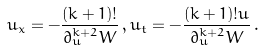<formula> <loc_0><loc_0><loc_500><loc_500>u _ { x } = - \frac { ( k + 1 ) ! } { \partial _ { u } ^ { k + 2 } W } \, , u _ { t } = - \frac { ( k + 1 ) ! u } { \partial _ { u } ^ { k + 2 } W } \, .</formula> 